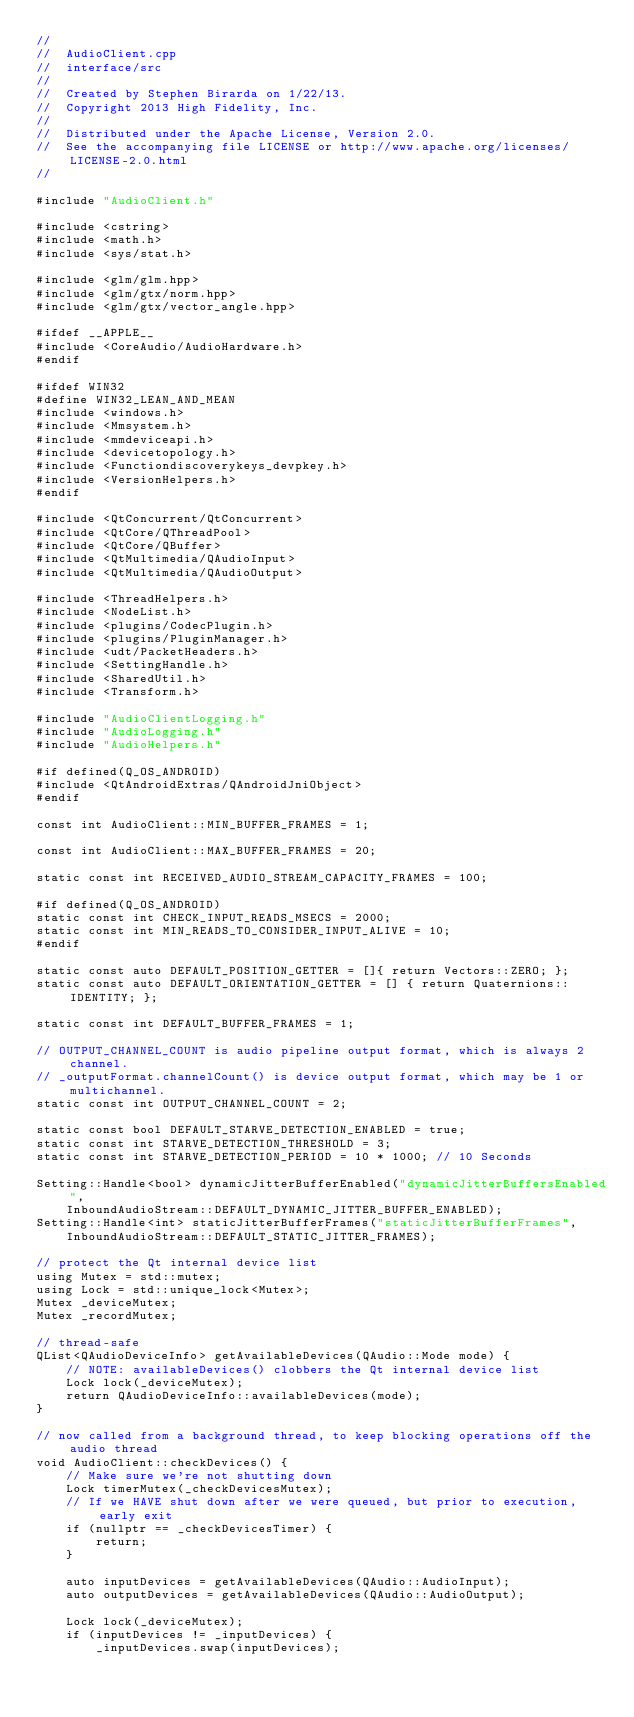Convert code to text. <code><loc_0><loc_0><loc_500><loc_500><_C++_>//
//  AudioClient.cpp
//  interface/src
//
//  Created by Stephen Birarda on 1/22/13.
//  Copyright 2013 High Fidelity, Inc.
//
//  Distributed under the Apache License, Version 2.0.
//  See the accompanying file LICENSE or http://www.apache.org/licenses/LICENSE-2.0.html
//

#include "AudioClient.h"

#include <cstring>
#include <math.h>
#include <sys/stat.h>

#include <glm/glm.hpp>
#include <glm/gtx/norm.hpp>
#include <glm/gtx/vector_angle.hpp>

#ifdef __APPLE__
#include <CoreAudio/AudioHardware.h>
#endif

#ifdef WIN32
#define WIN32_LEAN_AND_MEAN
#include <windows.h>
#include <Mmsystem.h>
#include <mmdeviceapi.h>
#include <devicetopology.h>
#include <Functiondiscoverykeys_devpkey.h>
#include <VersionHelpers.h>
#endif

#include <QtConcurrent/QtConcurrent>
#include <QtCore/QThreadPool>
#include <QtCore/QBuffer>
#include <QtMultimedia/QAudioInput>
#include <QtMultimedia/QAudioOutput>

#include <ThreadHelpers.h>
#include <NodeList.h>
#include <plugins/CodecPlugin.h>
#include <plugins/PluginManager.h>
#include <udt/PacketHeaders.h>
#include <SettingHandle.h>
#include <SharedUtil.h>
#include <Transform.h>

#include "AudioClientLogging.h"
#include "AudioLogging.h"
#include "AudioHelpers.h"

#if defined(Q_OS_ANDROID)
#include <QtAndroidExtras/QAndroidJniObject>
#endif

const int AudioClient::MIN_BUFFER_FRAMES = 1;

const int AudioClient::MAX_BUFFER_FRAMES = 20;

static const int RECEIVED_AUDIO_STREAM_CAPACITY_FRAMES = 100;

#if defined(Q_OS_ANDROID)
static const int CHECK_INPUT_READS_MSECS = 2000;
static const int MIN_READS_TO_CONSIDER_INPUT_ALIVE = 10;
#endif

static const auto DEFAULT_POSITION_GETTER = []{ return Vectors::ZERO; };
static const auto DEFAULT_ORIENTATION_GETTER = [] { return Quaternions::IDENTITY; };

static const int DEFAULT_BUFFER_FRAMES = 1;

// OUTPUT_CHANNEL_COUNT is audio pipeline output format, which is always 2 channel.
// _outputFormat.channelCount() is device output format, which may be 1 or multichannel.
static const int OUTPUT_CHANNEL_COUNT = 2;

static const bool DEFAULT_STARVE_DETECTION_ENABLED = true;
static const int STARVE_DETECTION_THRESHOLD = 3;
static const int STARVE_DETECTION_PERIOD = 10 * 1000; // 10 Seconds

Setting::Handle<bool> dynamicJitterBufferEnabled("dynamicJitterBuffersEnabled",
    InboundAudioStream::DEFAULT_DYNAMIC_JITTER_BUFFER_ENABLED);
Setting::Handle<int> staticJitterBufferFrames("staticJitterBufferFrames",
    InboundAudioStream::DEFAULT_STATIC_JITTER_FRAMES);

// protect the Qt internal device list
using Mutex = std::mutex;
using Lock = std::unique_lock<Mutex>;
Mutex _deviceMutex;
Mutex _recordMutex;

// thread-safe
QList<QAudioDeviceInfo> getAvailableDevices(QAudio::Mode mode) {
    // NOTE: availableDevices() clobbers the Qt internal device list
    Lock lock(_deviceMutex);
    return QAudioDeviceInfo::availableDevices(mode);
}

// now called from a background thread, to keep blocking operations off the audio thread
void AudioClient::checkDevices() {
    // Make sure we're not shutting down
    Lock timerMutex(_checkDevicesMutex);
    // If we HAVE shut down after we were queued, but prior to execution, early exit
    if (nullptr == _checkDevicesTimer) {
        return;
    }

    auto inputDevices = getAvailableDevices(QAudio::AudioInput);
    auto outputDevices = getAvailableDevices(QAudio::AudioOutput);

    Lock lock(_deviceMutex);
    if (inputDevices != _inputDevices) {
        _inputDevices.swap(inputDevices);</code> 